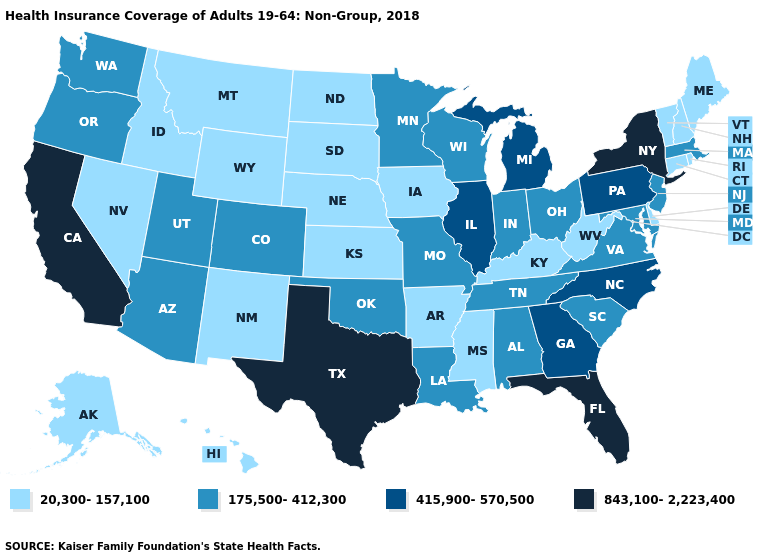What is the highest value in states that border Iowa?
Write a very short answer. 415,900-570,500. Name the states that have a value in the range 175,500-412,300?
Write a very short answer. Alabama, Arizona, Colorado, Indiana, Louisiana, Maryland, Massachusetts, Minnesota, Missouri, New Jersey, Ohio, Oklahoma, Oregon, South Carolina, Tennessee, Utah, Virginia, Washington, Wisconsin. What is the highest value in the West ?
Give a very brief answer. 843,100-2,223,400. Does Vermont have the lowest value in the Northeast?
Give a very brief answer. Yes. Does the map have missing data?
Write a very short answer. No. Name the states that have a value in the range 175,500-412,300?
Answer briefly. Alabama, Arizona, Colorado, Indiana, Louisiana, Maryland, Massachusetts, Minnesota, Missouri, New Jersey, Ohio, Oklahoma, Oregon, South Carolina, Tennessee, Utah, Virginia, Washington, Wisconsin. Name the states that have a value in the range 175,500-412,300?
Answer briefly. Alabama, Arizona, Colorado, Indiana, Louisiana, Maryland, Massachusetts, Minnesota, Missouri, New Jersey, Ohio, Oklahoma, Oregon, South Carolina, Tennessee, Utah, Virginia, Washington, Wisconsin. Does the map have missing data?
Answer briefly. No. Which states have the lowest value in the South?
Keep it brief. Arkansas, Delaware, Kentucky, Mississippi, West Virginia. Name the states that have a value in the range 415,900-570,500?
Write a very short answer. Georgia, Illinois, Michigan, North Carolina, Pennsylvania. Name the states that have a value in the range 415,900-570,500?
Give a very brief answer. Georgia, Illinois, Michigan, North Carolina, Pennsylvania. What is the lowest value in states that border Virginia?
Be succinct. 20,300-157,100. What is the value of Mississippi?
Give a very brief answer. 20,300-157,100. What is the lowest value in the USA?
Answer briefly. 20,300-157,100. How many symbols are there in the legend?
Answer briefly. 4. 